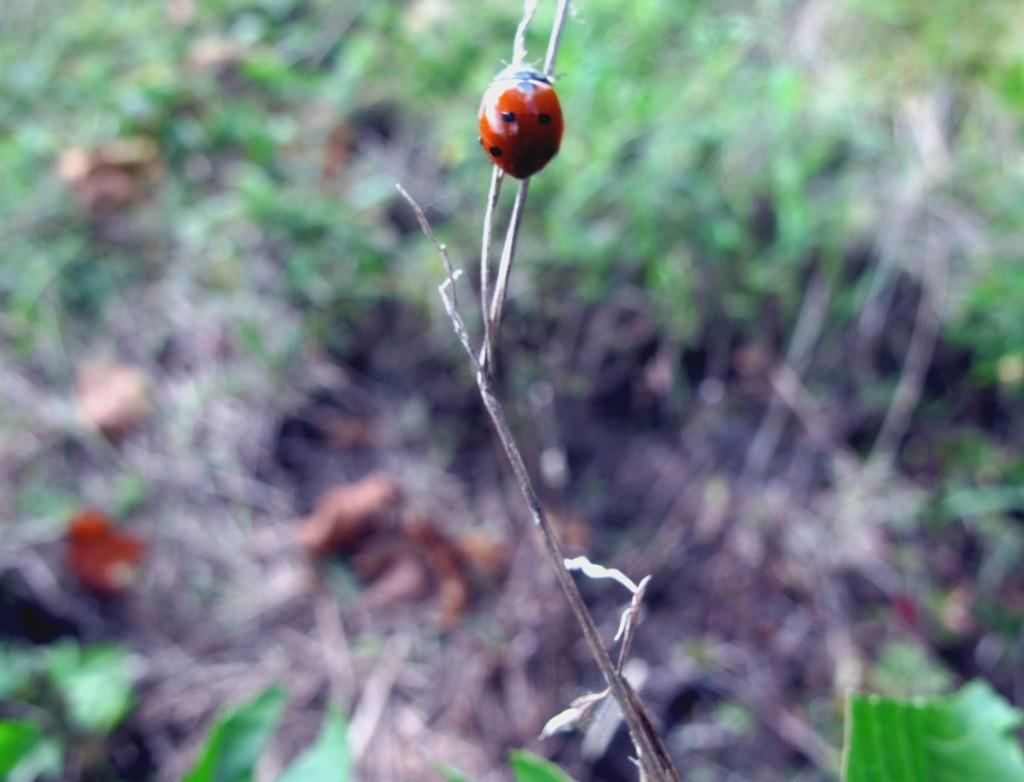What insect is present on a branch in the image? There is a ladybug on a branch in the image. Can you describe the background of the image? The background is blurred in the image. What is the ladybug's opinion on the bread in the image? There is no bread present in the image, and insects do not have opinions. 